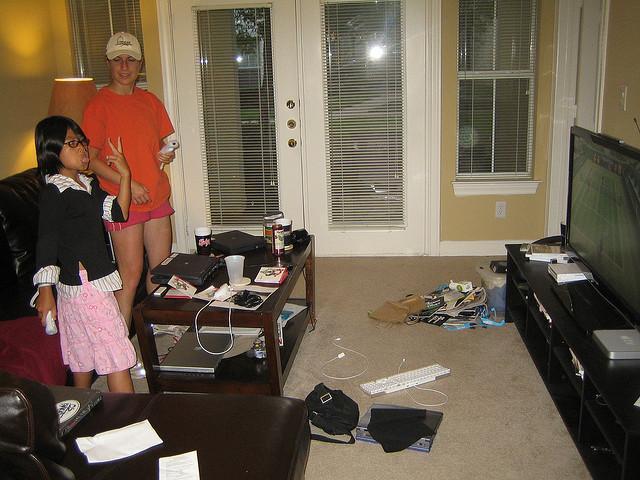How many people are visible?
Give a very brief answer. 2. How many couches are there?
Give a very brief answer. 2. How many chairs have blue blankets on them?
Give a very brief answer. 0. 